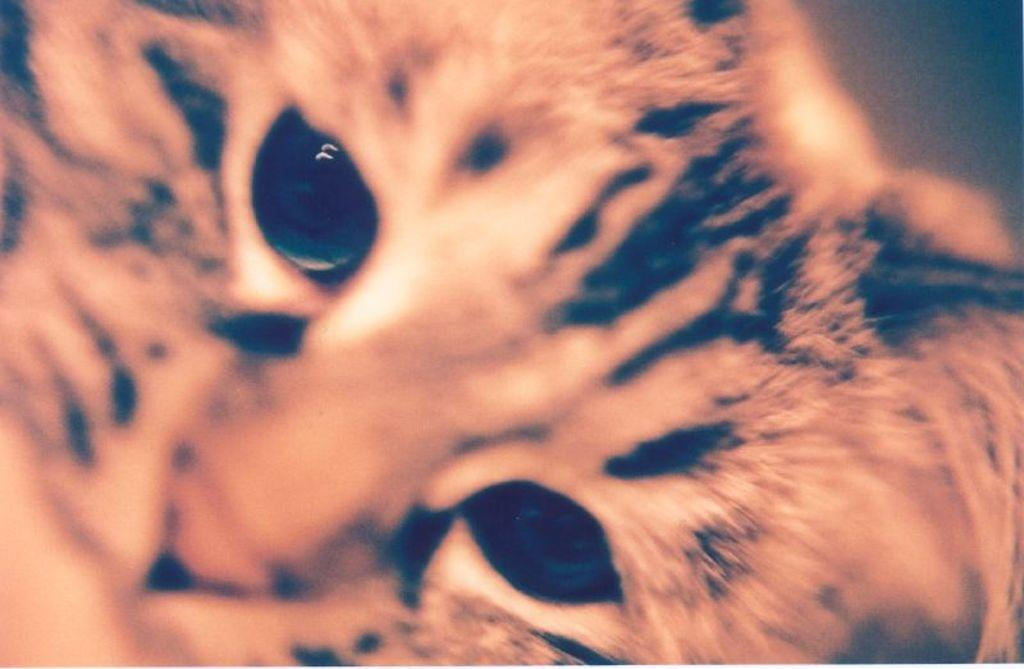What is the main subject of the image? The main subject of the image is a cat's face. What type of guitar is the cat playing with its toes in the image? There is no guitar or toes present in the image; it only features a cat's face. 